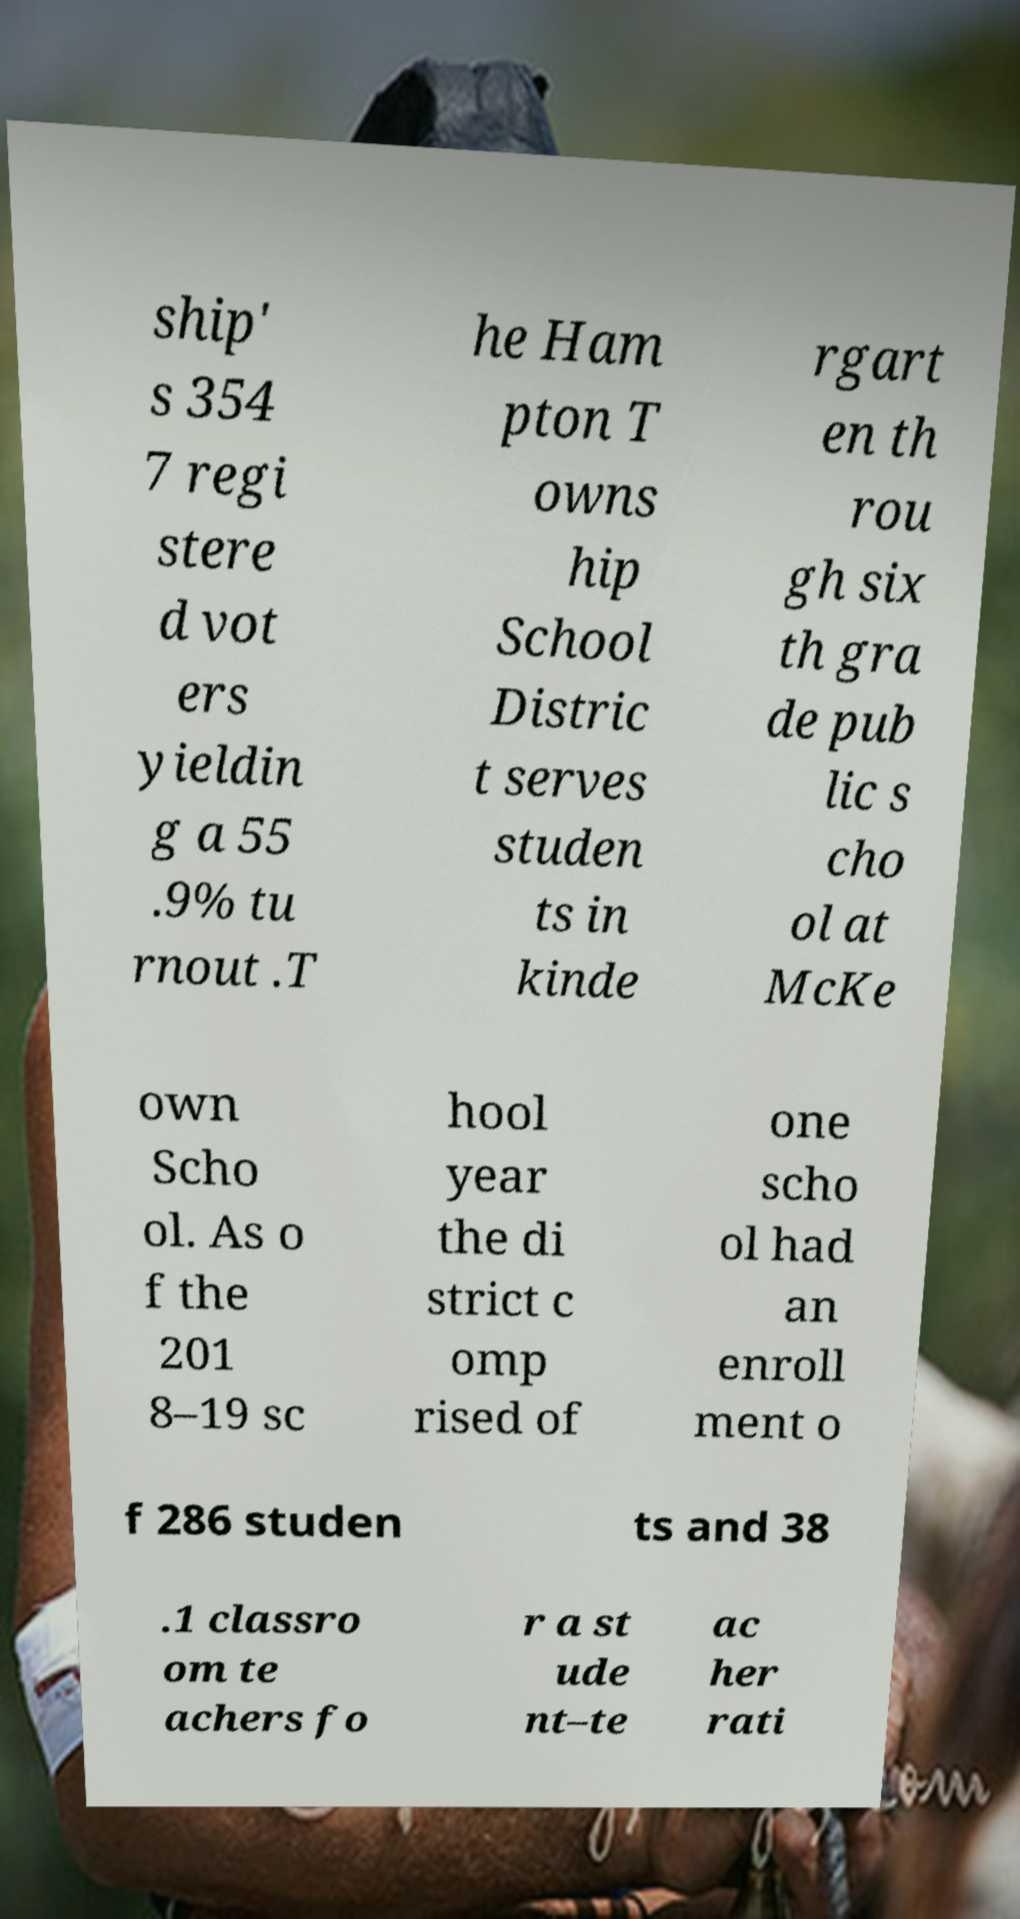Could you extract and type out the text from this image? ship' s 354 7 regi stere d vot ers yieldin g a 55 .9% tu rnout .T he Ham pton T owns hip School Distric t serves studen ts in kinde rgart en th rou gh six th gra de pub lic s cho ol at McKe own Scho ol. As o f the 201 8–19 sc hool year the di strict c omp rised of one scho ol had an enroll ment o f 286 studen ts and 38 .1 classro om te achers fo r a st ude nt–te ac her rati 